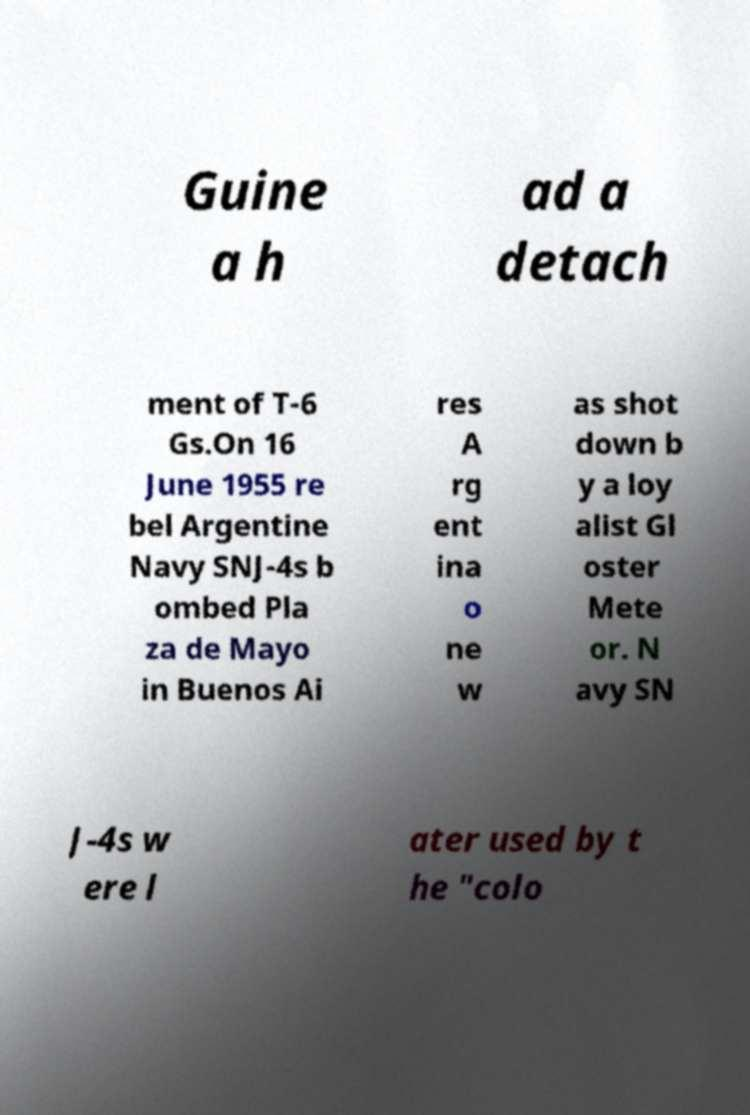Can you accurately transcribe the text from the provided image for me? Guine a h ad a detach ment of T-6 Gs.On 16 June 1955 re bel Argentine Navy SNJ-4s b ombed Pla za de Mayo in Buenos Ai res A rg ent ina o ne w as shot down b y a loy alist Gl oster Mete or. N avy SN J-4s w ere l ater used by t he "colo 